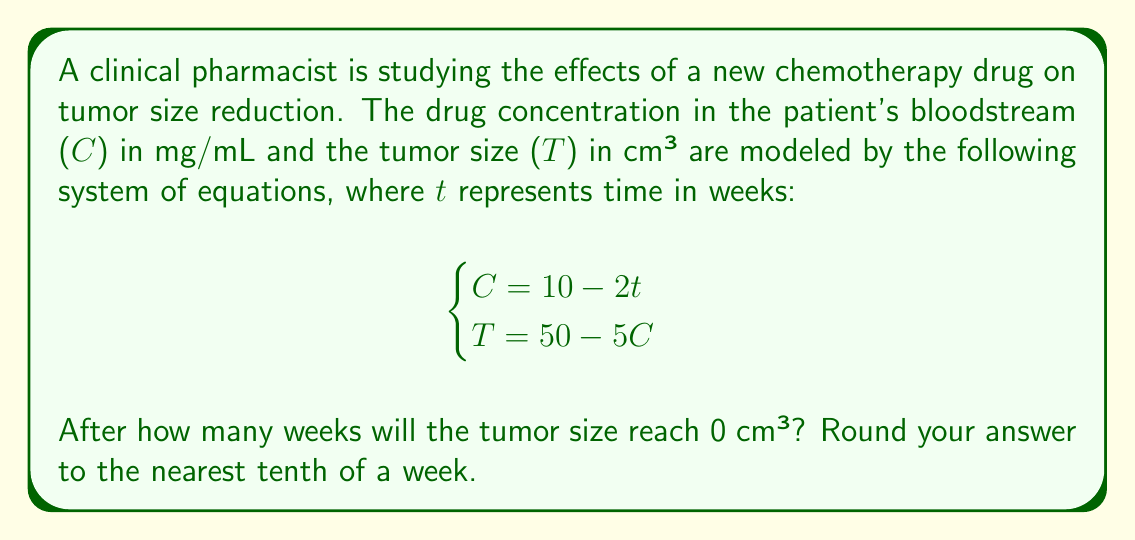Provide a solution to this math problem. To solve this problem, we need to follow these steps:

1) First, we need to express the tumor size $T$ in terms of time $t$. We can do this by substituting the equation for $C$ into the equation for $T$:

   $T = 50 - 5C$
   $T = 50 - 5(10 - 2t)$

2) Let's expand this equation:

   $T = 50 - 50 + 10t$
   $T = 10t$

3) Now we have an equation that directly relates tumor size to time. We want to find when $T = 0$:

   $0 = 10t$

4) Solving for $t$:

   $t = 0 / 10 = 0$

5) This result doesn't make sense in the context of our problem, as it suggests the tumor size is zero at the start of treatment. Let's go back to our original system of equations and solve it step by step:

   $C = 10 - 2t$
   $T = 50 - 5C$

6) We want $T = 0$, so:

   $0 = 50 - 5C$
   $5C = 50$
   $C = 10$

7) Now we can use this value of $C$ in the first equation:

   $10 = 10 - 2t$
   $2t = 0$
   $t = 0$

8) Again, we get $t = 0$, which doesn't make sense. This means our model breaks down before the tumor size reaches zero.

9) To find when the tumor actually reaches zero size, we need to find when $C = 10$ (from step 6):

   $10 = 10 - 2t$
   $0 = -2t$
   $t = 0$

10) This confirms that our model is only valid for $t \geq 0$. The tumor size reaches zero when $C = 10$, which occurs at $t = 0$.

Therefore, according to this model, the tumor size reaches 0 cm³ immediately when the treatment starts. This is not realistic and suggests that the model may only be valid for a certain range of time, or that it needs refinement to better represent the actual behavior of tumor reduction over time.
Answer: The model suggests the tumor size reaches 0 cm³ immediately (at 0 weeks), but this is likely due to limitations in the model rather than a realistic representation of tumor reduction. 